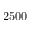Convert formula to latex. <formula><loc_0><loc_0><loc_500><loc_500>2 5 0 0</formula> 